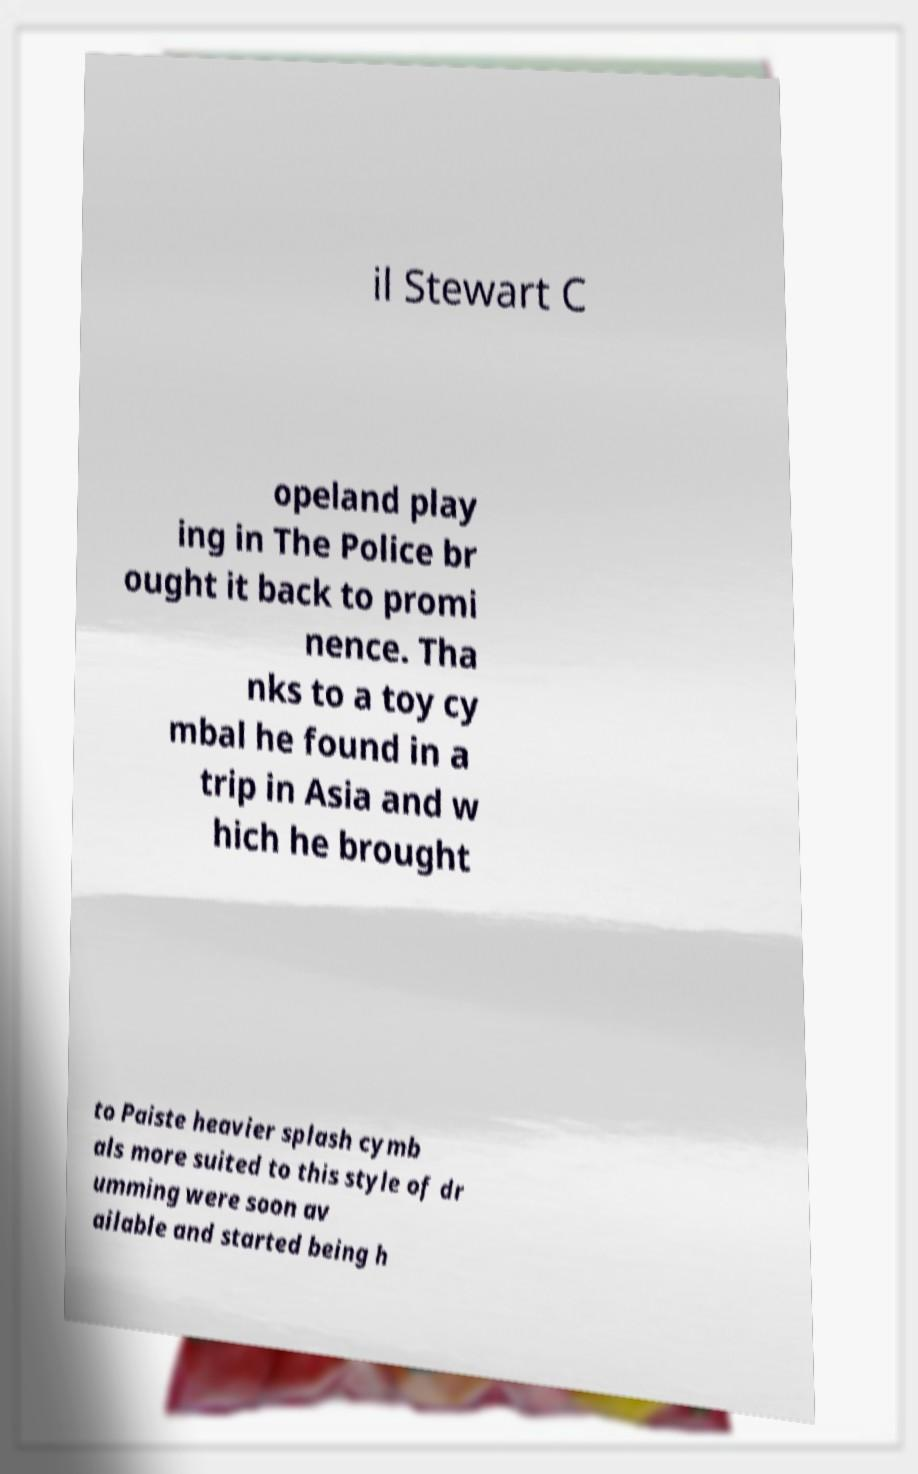Could you assist in decoding the text presented in this image and type it out clearly? il Stewart C opeland play ing in The Police br ought it back to promi nence. Tha nks to a toy cy mbal he found in a trip in Asia and w hich he brought to Paiste heavier splash cymb als more suited to this style of dr umming were soon av ailable and started being h 